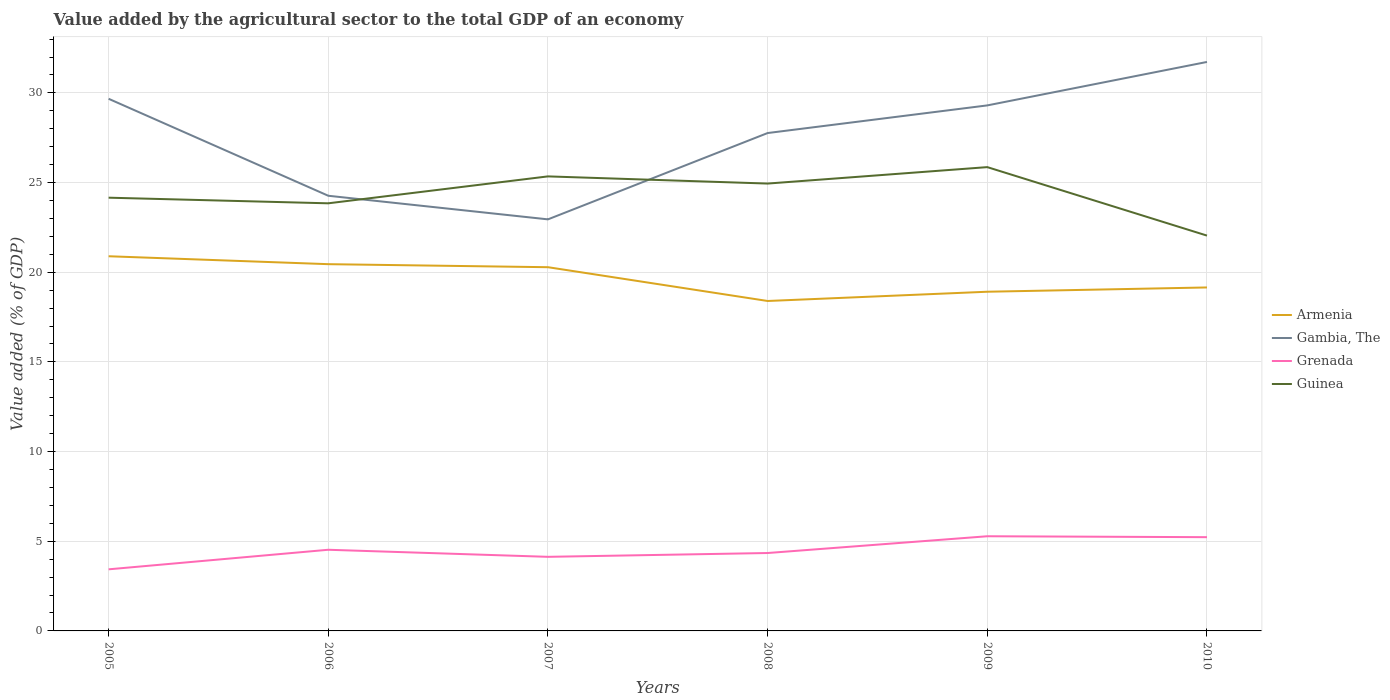How many different coloured lines are there?
Provide a short and direct response. 4. Is the number of lines equal to the number of legend labels?
Make the answer very short. Yes. Across all years, what is the maximum value added by the agricultural sector to the total GDP in Guinea?
Give a very brief answer. 22.04. In which year was the value added by the agricultural sector to the total GDP in Guinea maximum?
Provide a succinct answer. 2010. What is the total value added by the agricultural sector to the total GDP in Guinea in the graph?
Offer a terse response. 0.4. What is the difference between the highest and the second highest value added by the agricultural sector to the total GDP in Grenada?
Give a very brief answer. 1.84. Is the value added by the agricultural sector to the total GDP in Armenia strictly greater than the value added by the agricultural sector to the total GDP in Gambia, The over the years?
Make the answer very short. Yes. How many lines are there?
Provide a short and direct response. 4. Does the graph contain any zero values?
Provide a succinct answer. No. Does the graph contain grids?
Your answer should be compact. Yes. How are the legend labels stacked?
Give a very brief answer. Vertical. What is the title of the graph?
Your answer should be compact. Value added by the agricultural sector to the total GDP of an economy. What is the label or title of the X-axis?
Offer a terse response. Years. What is the label or title of the Y-axis?
Provide a succinct answer. Value added (% of GDP). What is the Value added (% of GDP) in Armenia in 2005?
Ensure brevity in your answer.  20.89. What is the Value added (% of GDP) of Gambia, The in 2005?
Make the answer very short. 29.67. What is the Value added (% of GDP) of Grenada in 2005?
Keep it short and to the point. 3.43. What is the Value added (% of GDP) of Guinea in 2005?
Your response must be concise. 24.16. What is the Value added (% of GDP) of Armenia in 2006?
Give a very brief answer. 20.45. What is the Value added (% of GDP) of Gambia, The in 2006?
Provide a succinct answer. 24.27. What is the Value added (% of GDP) of Grenada in 2006?
Provide a succinct answer. 4.53. What is the Value added (% of GDP) in Guinea in 2006?
Make the answer very short. 23.84. What is the Value added (% of GDP) in Armenia in 2007?
Ensure brevity in your answer.  20.28. What is the Value added (% of GDP) in Gambia, The in 2007?
Your answer should be compact. 22.95. What is the Value added (% of GDP) of Grenada in 2007?
Keep it short and to the point. 4.13. What is the Value added (% of GDP) in Guinea in 2007?
Your response must be concise. 25.35. What is the Value added (% of GDP) in Armenia in 2008?
Ensure brevity in your answer.  18.4. What is the Value added (% of GDP) of Gambia, The in 2008?
Keep it short and to the point. 27.76. What is the Value added (% of GDP) in Grenada in 2008?
Keep it short and to the point. 4.34. What is the Value added (% of GDP) of Guinea in 2008?
Your answer should be compact. 24.95. What is the Value added (% of GDP) in Armenia in 2009?
Provide a short and direct response. 18.91. What is the Value added (% of GDP) in Gambia, The in 2009?
Give a very brief answer. 29.3. What is the Value added (% of GDP) of Grenada in 2009?
Your answer should be compact. 5.28. What is the Value added (% of GDP) in Guinea in 2009?
Keep it short and to the point. 25.86. What is the Value added (% of GDP) of Armenia in 2010?
Offer a terse response. 19.15. What is the Value added (% of GDP) of Gambia, The in 2010?
Make the answer very short. 31.73. What is the Value added (% of GDP) in Grenada in 2010?
Your answer should be very brief. 5.23. What is the Value added (% of GDP) of Guinea in 2010?
Provide a succinct answer. 22.04. Across all years, what is the maximum Value added (% of GDP) of Armenia?
Your answer should be very brief. 20.89. Across all years, what is the maximum Value added (% of GDP) of Gambia, The?
Offer a terse response. 31.73. Across all years, what is the maximum Value added (% of GDP) of Grenada?
Offer a terse response. 5.28. Across all years, what is the maximum Value added (% of GDP) of Guinea?
Your answer should be very brief. 25.86. Across all years, what is the minimum Value added (% of GDP) in Armenia?
Offer a terse response. 18.4. Across all years, what is the minimum Value added (% of GDP) in Gambia, The?
Your response must be concise. 22.95. Across all years, what is the minimum Value added (% of GDP) in Grenada?
Keep it short and to the point. 3.43. Across all years, what is the minimum Value added (% of GDP) of Guinea?
Ensure brevity in your answer.  22.04. What is the total Value added (% of GDP) in Armenia in the graph?
Your response must be concise. 118.09. What is the total Value added (% of GDP) of Gambia, The in the graph?
Ensure brevity in your answer.  165.68. What is the total Value added (% of GDP) in Grenada in the graph?
Offer a terse response. 26.94. What is the total Value added (% of GDP) in Guinea in the graph?
Your answer should be compact. 146.2. What is the difference between the Value added (% of GDP) in Armenia in 2005 and that in 2006?
Your response must be concise. 0.44. What is the difference between the Value added (% of GDP) in Gambia, The in 2005 and that in 2006?
Provide a short and direct response. 5.41. What is the difference between the Value added (% of GDP) in Grenada in 2005 and that in 2006?
Your response must be concise. -1.09. What is the difference between the Value added (% of GDP) of Guinea in 2005 and that in 2006?
Provide a succinct answer. 0.31. What is the difference between the Value added (% of GDP) of Armenia in 2005 and that in 2007?
Ensure brevity in your answer.  0.61. What is the difference between the Value added (% of GDP) of Gambia, The in 2005 and that in 2007?
Your answer should be very brief. 6.72. What is the difference between the Value added (% of GDP) in Grenada in 2005 and that in 2007?
Ensure brevity in your answer.  -0.7. What is the difference between the Value added (% of GDP) in Guinea in 2005 and that in 2007?
Make the answer very short. -1.19. What is the difference between the Value added (% of GDP) of Armenia in 2005 and that in 2008?
Make the answer very short. 2.49. What is the difference between the Value added (% of GDP) of Gambia, The in 2005 and that in 2008?
Your response must be concise. 1.91. What is the difference between the Value added (% of GDP) in Grenada in 2005 and that in 2008?
Offer a very short reply. -0.91. What is the difference between the Value added (% of GDP) of Guinea in 2005 and that in 2008?
Offer a very short reply. -0.79. What is the difference between the Value added (% of GDP) of Armenia in 2005 and that in 2009?
Make the answer very short. 1.98. What is the difference between the Value added (% of GDP) of Gambia, The in 2005 and that in 2009?
Provide a succinct answer. 0.37. What is the difference between the Value added (% of GDP) of Grenada in 2005 and that in 2009?
Provide a succinct answer. -1.84. What is the difference between the Value added (% of GDP) of Guinea in 2005 and that in 2009?
Ensure brevity in your answer.  -1.7. What is the difference between the Value added (% of GDP) in Armenia in 2005 and that in 2010?
Your answer should be very brief. 1.74. What is the difference between the Value added (% of GDP) in Gambia, The in 2005 and that in 2010?
Your answer should be compact. -2.05. What is the difference between the Value added (% of GDP) in Grenada in 2005 and that in 2010?
Your response must be concise. -1.79. What is the difference between the Value added (% of GDP) of Guinea in 2005 and that in 2010?
Your answer should be compact. 2.11. What is the difference between the Value added (% of GDP) of Armenia in 2006 and that in 2007?
Your response must be concise. 0.17. What is the difference between the Value added (% of GDP) of Gambia, The in 2006 and that in 2007?
Offer a terse response. 1.32. What is the difference between the Value added (% of GDP) in Grenada in 2006 and that in 2007?
Offer a very short reply. 0.39. What is the difference between the Value added (% of GDP) in Guinea in 2006 and that in 2007?
Keep it short and to the point. -1.5. What is the difference between the Value added (% of GDP) of Armenia in 2006 and that in 2008?
Keep it short and to the point. 2.05. What is the difference between the Value added (% of GDP) of Gambia, The in 2006 and that in 2008?
Make the answer very short. -3.5. What is the difference between the Value added (% of GDP) in Grenada in 2006 and that in 2008?
Keep it short and to the point. 0.18. What is the difference between the Value added (% of GDP) of Guinea in 2006 and that in 2008?
Ensure brevity in your answer.  -1.1. What is the difference between the Value added (% of GDP) in Armenia in 2006 and that in 2009?
Your answer should be compact. 1.54. What is the difference between the Value added (% of GDP) in Gambia, The in 2006 and that in 2009?
Give a very brief answer. -5.04. What is the difference between the Value added (% of GDP) in Grenada in 2006 and that in 2009?
Offer a terse response. -0.75. What is the difference between the Value added (% of GDP) of Guinea in 2006 and that in 2009?
Offer a very short reply. -2.02. What is the difference between the Value added (% of GDP) of Armenia in 2006 and that in 2010?
Your answer should be compact. 1.3. What is the difference between the Value added (% of GDP) in Gambia, The in 2006 and that in 2010?
Offer a terse response. -7.46. What is the difference between the Value added (% of GDP) in Grenada in 2006 and that in 2010?
Provide a succinct answer. -0.7. What is the difference between the Value added (% of GDP) in Guinea in 2006 and that in 2010?
Your response must be concise. 1.8. What is the difference between the Value added (% of GDP) in Armenia in 2007 and that in 2008?
Your response must be concise. 1.88. What is the difference between the Value added (% of GDP) in Gambia, The in 2007 and that in 2008?
Offer a terse response. -4.81. What is the difference between the Value added (% of GDP) in Grenada in 2007 and that in 2008?
Provide a short and direct response. -0.21. What is the difference between the Value added (% of GDP) of Guinea in 2007 and that in 2008?
Offer a very short reply. 0.4. What is the difference between the Value added (% of GDP) in Armenia in 2007 and that in 2009?
Give a very brief answer. 1.37. What is the difference between the Value added (% of GDP) of Gambia, The in 2007 and that in 2009?
Your answer should be compact. -6.35. What is the difference between the Value added (% of GDP) in Grenada in 2007 and that in 2009?
Ensure brevity in your answer.  -1.15. What is the difference between the Value added (% of GDP) of Guinea in 2007 and that in 2009?
Your response must be concise. -0.52. What is the difference between the Value added (% of GDP) in Armenia in 2007 and that in 2010?
Provide a short and direct response. 1.13. What is the difference between the Value added (% of GDP) of Gambia, The in 2007 and that in 2010?
Give a very brief answer. -8.78. What is the difference between the Value added (% of GDP) in Grenada in 2007 and that in 2010?
Offer a very short reply. -1.1. What is the difference between the Value added (% of GDP) of Guinea in 2007 and that in 2010?
Provide a short and direct response. 3.3. What is the difference between the Value added (% of GDP) of Armenia in 2008 and that in 2009?
Provide a short and direct response. -0.52. What is the difference between the Value added (% of GDP) in Gambia, The in 2008 and that in 2009?
Make the answer very short. -1.54. What is the difference between the Value added (% of GDP) in Grenada in 2008 and that in 2009?
Keep it short and to the point. -0.94. What is the difference between the Value added (% of GDP) in Guinea in 2008 and that in 2009?
Offer a terse response. -0.92. What is the difference between the Value added (% of GDP) of Armenia in 2008 and that in 2010?
Offer a terse response. -0.75. What is the difference between the Value added (% of GDP) of Gambia, The in 2008 and that in 2010?
Make the answer very short. -3.96. What is the difference between the Value added (% of GDP) of Grenada in 2008 and that in 2010?
Your answer should be compact. -0.88. What is the difference between the Value added (% of GDP) in Guinea in 2008 and that in 2010?
Provide a short and direct response. 2.9. What is the difference between the Value added (% of GDP) of Armenia in 2009 and that in 2010?
Offer a very short reply. -0.24. What is the difference between the Value added (% of GDP) of Gambia, The in 2009 and that in 2010?
Your response must be concise. -2.42. What is the difference between the Value added (% of GDP) of Grenada in 2009 and that in 2010?
Your response must be concise. 0.05. What is the difference between the Value added (% of GDP) in Guinea in 2009 and that in 2010?
Offer a very short reply. 3.82. What is the difference between the Value added (% of GDP) in Armenia in 2005 and the Value added (% of GDP) in Gambia, The in 2006?
Offer a very short reply. -3.37. What is the difference between the Value added (% of GDP) of Armenia in 2005 and the Value added (% of GDP) of Grenada in 2006?
Provide a succinct answer. 16.37. What is the difference between the Value added (% of GDP) of Armenia in 2005 and the Value added (% of GDP) of Guinea in 2006?
Provide a succinct answer. -2.95. What is the difference between the Value added (% of GDP) of Gambia, The in 2005 and the Value added (% of GDP) of Grenada in 2006?
Offer a very short reply. 25.15. What is the difference between the Value added (% of GDP) of Gambia, The in 2005 and the Value added (% of GDP) of Guinea in 2006?
Make the answer very short. 5.83. What is the difference between the Value added (% of GDP) in Grenada in 2005 and the Value added (% of GDP) in Guinea in 2006?
Provide a succinct answer. -20.41. What is the difference between the Value added (% of GDP) of Armenia in 2005 and the Value added (% of GDP) of Gambia, The in 2007?
Give a very brief answer. -2.06. What is the difference between the Value added (% of GDP) of Armenia in 2005 and the Value added (% of GDP) of Grenada in 2007?
Make the answer very short. 16.76. What is the difference between the Value added (% of GDP) in Armenia in 2005 and the Value added (% of GDP) in Guinea in 2007?
Your response must be concise. -4.45. What is the difference between the Value added (% of GDP) in Gambia, The in 2005 and the Value added (% of GDP) in Grenada in 2007?
Keep it short and to the point. 25.54. What is the difference between the Value added (% of GDP) of Gambia, The in 2005 and the Value added (% of GDP) of Guinea in 2007?
Your answer should be very brief. 4.33. What is the difference between the Value added (% of GDP) of Grenada in 2005 and the Value added (% of GDP) of Guinea in 2007?
Your answer should be very brief. -21.91. What is the difference between the Value added (% of GDP) in Armenia in 2005 and the Value added (% of GDP) in Gambia, The in 2008?
Your response must be concise. -6.87. What is the difference between the Value added (% of GDP) in Armenia in 2005 and the Value added (% of GDP) in Grenada in 2008?
Your response must be concise. 16.55. What is the difference between the Value added (% of GDP) of Armenia in 2005 and the Value added (% of GDP) of Guinea in 2008?
Offer a very short reply. -4.05. What is the difference between the Value added (% of GDP) of Gambia, The in 2005 and the Value added (% of GDP) of Grenada in 2008?
Offer a very short reply. 25.33. What is the difference between the Value added (% of GDP) in Gambia, The in 2005 and the Value added (% of GDP) in Guinea in 2008?
Provide a succinct answer. 4.73. What is the difference between the Value added (% of GDP) of Grenada in 2005 and the Value added (% of GDP) of Guinea in 2008?
Your answer should be compact. -21.51. What is the difference between the Value added (% of GDP) in Armenia in 2005 and the Value added (% of GDP) in Gambia, The in 2009?
Give a very brief answer. -8.41. What is the difference between the Value added (% of GDP) of Armenia in 2005 and the Value added (% of GDP) of Grenada in 2009?
Make the answer very short. 15.61. What is the difference between the Value added (% of GDP) of Armenia in 2005 and the Value added (% of GDP) of Guinea in 2009?
Provide a succinct answer. -4.97. What is the difference between the Value added (% of GDP) of Gambia, The in 2005 and the Value added (% of GDP) of Grenada in 2009?
Your answer should be very brief. 24.39. What is the difference between the Value added (% of GDP) of Gambia, The in 2005 and the Value added (% of GDP) of Guinea in 2009?
Give a very brief answer. 3.81. What is the difference between the Value added (% of GDP) of Grenada in 2005 and the Value added (% of GDP) of Guinea in 2009?
Ensure brevity in your answer.  -22.43. What is the difference between the Value added (% of GDP) in Armenia in 2005 and the Value added (% of GDP) in Gambia, The in 2010?
Your answer should be very brief. -10.84. What is the difference between the Value added (% of GDP) in Armenia in 2005 and the Value added (% of GDP) in Grenada in 2010?
Offer a terse response. 15.66. What is the difference between the Value added (% of GDP) in Armenia in 2005 and the Value added (% of GDP) in Guinea in 2010?
Offer a terse response. -1.15. What is the difference between the Value added (% of GDP) in Gambia, The in 2005 and the Value added (% of GDP) in Grenada in 2010?
Your response must be concise. 24.45. What is the difference between the Value added (% of GDP) in Gambia, The in 2005 and the Value added (% of GDP) in Guinea in 2010?
Your response must be concise. 7.63. What is the difference between the Value added (% of GDP) of Grenada in 2005 and the Value added (% of GDP) of Guinea in 2010?
Ensure brevity in your answer.  -18.61. What is the difference between the Value added (% of GDP) of Armenia in 2006 and the Value added (% of GDP) of Gambia, The in 2007?
Provide a succinct answer. -2.5. What is the difference between the Value added (% of GDP) in Armenia in 2006 and the Value added (% of GDP) in Grenada in 2007?
Provide a succinct answer. 16.32. What is the difference between the Value added (% of GDP) of Armenia in 2006 and the Value added (% of GDP) of Guinea in 2007?
Keep it short and to the point. -4.89. What is the difference between the Value added (% of GDP) of Gambia, The in 2006 and the Value added (% of GDP) of Grenada in 2007?
Your answer should be very brief. 20.13. What is the difference between the Value added (% of GDP) of Gambia, The in 2006 and the Value added (% of GDP) of Guinea in 2007?
Keep it short and to the point. -1.08. What is the difference between the Value added (% of GDP) in Grenada in 2006 and the Value added (% of GDP) in Guinea in 2007?
Provide a short and direct response. -20.82. What is the difference between the Value added (% of GDP) of Armenia in 2006 and the Value added (% of GDP) of Gambia, The in 2008?
Keep it short and to the point. -7.31. What is the difference between the Value added (% of GDP) of Armenia in 2006 and the Value added (% of GDP) of Grenada in 2008?
Ensure brevity in your answer.  16.11. What is the difference between the Value added (% of GDP) of Armenia in 2006 and the Value added (% of GDP) of Guinea in 2008?
Your response must be concise. -4.49. What is the difference between the Value added (% of GDP) in Gambia, The in 2006 and the Value added (% of GDP) in Grenada in 2008?
Provide a short and direct response. 19.92. What is the difference between the Value added (% of GDP) of Gambia, The in 2006 and the Value added (% of GDP) of Guinea in 2008?
Your answer should be compact. -0.68. What is the difference between the Value added (% of GDP) in Grenada in 2006 and the Value added (% of GDP) in Guinea in 2008?
Your answer should be compact. -20.42. What is the difference between the Value added (% of GDP) in Armenia in 2006 and the Value added (% of GDP) in Gambia, The in 2009?
Make the answer very short. -8.85. What is the difference between the Value added (% of GDP) in Armenia in 2006 and the Value added (% of GDP) in Grenada in 2009?
Offer a very short reply. 15.17. What is the difference between the Value added (% of GDP) of Armenia in 2006 and the Value added (% of GDP) of Guinea in 2009?
Your answer should be compact. -5.41. What is the difference between the Value added (% of GDP) of Gambia, The in 2006 and the Value added (% of GDP) of Grenada in 2009?
Offer a very short reply. 18.99. What is the difference between the Value added (% of GDP) of Gambia, The in 2006 and the Value added (% of GDP) of Guinea in 2009?
Ensure brevity in your answer.  -1.6. What is the difference between the Value added (% of GDP) in Grenada in 2006 and the Value added (% of GDP) in Guinea in 2009?
Your answer should be compact. -21.34. What is the difference between the Value added (% of GDP) of Armenia in 2006 and the Value added (% of GDP) of Gambia, The in 2010?
Make the answer very short. -11.28. What is the difference between the Value added (% of GDP) in Armenia in 2006 and the Value added (% of GDP) in Grenada in 2010?
Offer a terse response. 15.22. What is the difference between the Value added (% of GDP) of Armenia in 2006 and the Value added (% of GDP) of Guinea in 2010?
Your response must be concise. -1.59. What is the difference between the Value added (% of GDP) of Gambia, The in 2006 and the Value added (% of GDP) of Grenada in 2010?
Your answer should be very brief. 19.04. What is the difference between the Value added (% of GDP) in Gambia, The in 2006 and the Value added (% of GDP) in Guinea in 2010?
Your answer should be compact. 2.22. What is the difference between the Value added (% of GDP) in Grenada in 2006 and the Value added (% of GDP) in Guinea in 2010?
Make the answer very short. -17.52. What is the difference between the Value added (% of GDP) in Armenia in 2007 and the Value added (% of GDP) in Gambia, The in 2008?
Your answer should be compact. -7.48. What is the difference between the Value added (% of GDP) of Armenia in 2007 and the Value added (% of GDP) of Grenada in 2008?
Your answer should be compact. 15.94. What is the difference between the Value added (% of GDP) in Armenia in 2007 and the Value added (% of GDP) in Guinea in 2008?
Ensure brevity in your answer.  -4.66. What is the difference between the Value added (% of GDP) in Gambia, The in 2007 and the Value added (% of GDP) in Grenada in 2008?
Give a very brief answer. 18.61. What is the difference between the Value added (% of GDP) of Gambia, The in 2007 and the Value added (% of GDP) of Guinea in 2008?
Offer a terse response. -2. What is the difference between the Value added (% of GDP) in Grenada in 2007 and the Value added (% of GDP) in Guinea in 2008?
Keep it short and to the point. -20.81. What is the difference between the Value added (% of GDP) of Armenia in 2007 and the Value added (% of GDP) of Gambia, The in 2009?
Your response must be concise. -9.02. What is the difference between the Value added (% of GDP) in Armenia in 2007 and the Value added (% of GDP) in Grenada in 2009?
Offer a terse response. 15. What is the difference between the Value added (% of GDP) in Armenia in 2007 and the Value added (% of GDP) in Guinea in 2009?
Keep it short and to the point. -5.58. What is the difference between the Value added (% of GDP) of Gambia, The in 2007 and the Value added (% of GDP) of Grenada in 2009?
Ensure brevity in your answer.  17.67. What is the difference between the Value added (% of GDP) of Gambia, The in 2007 and the Value added (% of GDP) of Guinea in 2009?
Keep it short and to the point. -2.91. What is the difference between the Value added (% of GDP) of Grenada in 2007 and the Value added (% of GDP) of Guinea in 2009?
Your answer should be compact. -21.73. What is the difference between the Value added (% of GDP) in Armenia in 2007 and the Value added (% of GDP) in Gambia, The in 2010?
Give a very brief answer. -11.45. What is the difference between the Value added (% of GDP) in Armenia in 2007 and the Value added (% of GDP) in Grenada in 2010?
Offer a very short reply. 15.05. What is the difference between the Value added (% of GDP) of Armenia in 2007 and the Value added (% of GDP) of Guinea in 2010?
Keep it short and to the point. -1.76. What is the difference between the Value added (% of GDP) in Gambia, The in 2007 and the Value added (% of GDP) in Grenada in 2010?
Your response must be concise. 17.72. What is the difference between the Value added (% of GDP) in Gambia, The in 2007 and the Value added (% of GDP) in Guinea in 2010?
Ensure brevity in your answer.  0.91. What is the difference between the Value added (% of GDP) in Grenada in 2007 and the Value added (% of GDP) in Guinea in 2010?
Your answer should be compact. -17.91. What is the difference between the Value added (% of GDP) in Armenia in 2008 and the Value added (% of GDP) in Gambia, The in 2009?
Ensure brevity in your answer.  -10.91. What is the difference between the Value added (% of GDP) in Armenia in 2008 and the Value added (% of GDP) in Grenada in 2009?
Your answer should be very brief. 13.12. What is the difference between the Value added (% of GDP) of Armenia in 2008 and the Value added (% of GDP) of Guinea in 2009?
Provide a short and direct response. -7.46. What is the difference between the Value added (% of GDP) in Gambia, The in 2008 and the Value added (% of GDP) in Grenada in 2009?
Keep it short and to the point. 22.48. What is the difference between the Value added (% of GDP) of Gambia, The in 2008 and the Value added (% of GDP) of Guinea in 2009?
Provide a succinct answer. 1.9. What is the difference between the Value added (% of GDP) of Grenada in 2008 and the Value added (% of GDP) of Guinea in 2009?
Provide a succinct answer. -21.52. What is the difference between the Value added (% of GDP) of Armenia in 2008 and the Value added (% of GDP) of Gambia, The in 2010?
Keep it short and to the point. -13.33. What is the difference between the Value added (% of GDP) in Armenia in 2008 and the Value added (% of GDP) in Grenada in 2010?
Offer a very short reply. 13.17. What is the difference between the Value added (% of GDP) of Armenia in 2008 and the Value added (% of GDP) of Guinea in 2010?
Your answer should be compact. -3.65. What is the difference between the Value added (% of GDP) in Gambia, The in 2008 and the Value added (% of GDP) in Grenada in 2010?
Provide a succinct answer. 22.54. What is the difference between the Value added (% of GDP) of Gambia, The in 2008 and the Value added (% of GDP) of Guinea in 2010?
Offer a terse response. 5.72. What is the difference between the Value added (% of GDP) in Grenada in 2008 and the Value added (% of GDP) in Guinea in 2010?
Offer a terse response. -17.7. What is the difference between the Value added (% of GDP) of Armenia in 2009 and the Value added (% of GDP) of Gambia, The in 2010?
Offer a very short reply. -12.81. What is the difference between the Value added (% of GDP) of Armenia in 2009 and the Value added (% of GDP) of Grenada in 2010?
Your answer should be very brief. 13.69. What is the difference between the Value added (% of GDP) of Armenia in 2009 and the Value added (% of GDP) of Guinea in 2010?
Your answer should be compact. -3.13. What is the difference between the Value added (% of GDP) in Gambia, The in 2009 and the Value added (% of GDP) in Grenada in 2010?
Keep it short and to the point. 24.08. What is the difference between the Value added (% of GDP) of Gambia, The in 2009 and the Value added (% of GDP) of Guinea in 2010?
Provide a succinct answer. 7.26. What is the difference between the Value added (% of GDP) in Grenada in 2009 and the Value added (% of GDP) in Guinea in 2010?
Ensure brevity in your answer.  -16.77. What is the average Value added (% of GDP) of Armenia per year?
Provide a succinct answer. 19.68. What is the average Value added (% of GDP) of Gambia, The per year?
Ensure brevity in your answer.  27.61. What is the average Value added (% of GDP) in Grenada per year?
Give a very brief answer. 4.49. What is the average Value added (% of GDP) in Guinea per year?
Your answer should be compact. 24.37. In the year 2005, what is the difference between the Value added (% of GDP) of Armenia and Value added (% of GDP) of Gambia, The?
Your answer should be compact. -8.78. In the year 2005, what is the difference between the Value added (% of GDP) in Armenia and Value added (% of GDP) in Grenada?
Your response must be concise. 17.46. In the year 2005, what is the difference between the Value added (% of GDP) of Armenia and Value added (% of GDP) of Guinea?
Your answer should be compact. -3.27. In the year 2005, what is the difference between the Value added (% of GDP) of Gambia, The and Value added (% of GDP) of Grenada?
Your response must be concise. 26.24. In the year 2005, what is the difference between the Value added (% of GDP) of Gambia, The and Value added (% of GDP) of Guinea?
Give a very brief answer. 5.51. In the year 2005, what is the difference between the Value added (% of GDP) of Grenada and Value added (% of GDP) of Guinea?
Your answer should be very brief. -20.72. In the year 2006, what is the difference between the Value added (% of GDP) in Armenia and Value added (% of GDP) in Gambia, The?
Your response must be concise. -3.81. In the year 2006, what is the difference between the Value added (% of GDP) of Armenia and Value added (% of GDP) of Grenada?
Ensure brevity in your answer.  15.93. In the year 2006, what is the difference between the Value added (% of GDP) of Armenia and Value added (% of GDP) of Guinea?
Ensure brevity in your answer.  -3.39. In the year 2006, what is the difference between the Value added (% of GDP) of Gambia, The and Value added (% of GDP) of Grenada?
Ensure brevity in your answer.  19.74. In the year 2006, what is the difference between the Value added (% of GDP) of Gambia, The and Value added (% of GDP) of Guinea?
Make the answer very short. 0.42. In the year 2006, what is the difference between the Value added (% of GDP) in Grenada and Value added (% of GDP) in Guinea?
Provide a succinct answer. -19.32. In the year 2007, what is the difference between the Value added (% of GDP) in Armenia and Value added (% of GDP) in Gambia, The?
Offer a terse response. -2.67. In the year 2007, what is the difference between the Value added (% of GDP) in Armenia and Value added (% of GDP) in Grenada?
Your answer should be very brief. 16.15. In the year 2007, what is the difference between the Value added (% of GDP) of Armenia and Value added (% of GDP) of Guinea?
Keep it short and to the point. -5.06. In the year 2007, what is the difference between the Value added (% of GDP) of Gambia, The and Value added (% of GDP) of Grenada?
Offer a very short reply. 18.82. In the year 2007, what is the difference between the Value added (% of GDP) in Gambia, The and Value added (% of GDP) in Guinea?
Ensure brevity in your answer.  -2.4. In the year 2007, what is the difference between the Value added (% of GDP) in Grenada and Value added (% of GDP) in Guinea?
Provide a short and direct response. -21.21. In the year 2008, what is the difference between the Value added (% of GDP) of Armenia and Value added (% of GDP) of Gambia, The?
Your answer should be very brief. -9.37. In the year 2008, what is the difference between the Value added (% of GDP) in Armenia and Value added (% of GDP) in Grenada?
Offer a very short reply. 14.05. In the year 2008, what is the difference between the Value added (% of GDP) in Armenia and Value added (% of GDP) in Guinea?
Your response must be concise. -6.55. In the year 2008, what is the difference between the Value added (% of GDP) in Gambia, The and Value added (% of GDP) in Grenada?
Give a very brief answer. 23.42. In the year 2008, what is the difference between the Value added (% of GDP) of Gambia, The and Value added (% of GDP) of Guinea?
Offer a terse response. 2.82. In the year 2008, what is the difference between the Value added (% of GDP) in Grenada and Value added (% of GDP) in Guinea?
Your answer should be very brief. -20.6. In the year 2009, what is the difference between the Value added (% of GDP) of Armenia and Value added (% of GDP) of Gambia, The?
Provide a succinct answer. -10.39. In the year 2009, what is the difference between the Value added (% of GDP) in Armenia and Value added (% of GDP) in Grenada?
Your response must be concise. 13.63. In the year 2009, what is the difference between the Value added (% of GDP) in Armenia and Value added (% of GDP) in Guinea?
Your response must be concise. -6.95. In the year 2009, what is the difference between the Value added (% of GDP) in Gambia, The and Value added (% of GDP) in Grenada?
Your answer should be very brief. 24.03. In the year 2009, what is the difference between the Value added (% of GDP) of Gambia, The and Value added (% of GDP) of Guinea?
Your answer should be compact. 3.44. In the year 2009, what is the difference between the Value added (% of GDP) in Grenada and Value added (% of GDP) in Guinea?
Provide a short and direct response. -20.58. In the year 2010, what is the difference between the Value added (% of GDP) in Armenia and Value added (% of GDP) in Gambia, The?
Give a very brief answer. -12.57. In the year 2010, what is the difference between the Value added (% of GDP) in Armenia and Value added (% of GDP) in Grenada?
Your answer should be compact. 13.93. In the year 2010, what is the difference between the Value added (% of GDP) in Armenia and Value added (% of GDP) in Guinea?
Offer a terse response. -2.89. In the year 2010, what is the difference between the Value added (% of GDP) in Gambia, The and Value added (% of GDP) in Grenada?
Keep it short and to the point. 26.5. In the year 2010, what is the difference between the Value added (% of GDP) in Gambia, The and Value added (% of GDP) in Guinea?
Provide a short and direct response. 9.68. In the year 2010, what is the difference between the Value added (% of GDP) in Grenada and Value added (% of GDP) in Guinea?
Provide a short and direct response. -16.82. What is the ratio of the Value added (% of GDP) in Armenia in 2005 to that in 2006?
Make the answer very short. 1.02. What is the ratio of the Value added (% of GDP) in Gambia, The in 2005 to that in 2006?
Your response must be concise. 1.22. What is the ratio of the Value added (% of GDP) of Grenada in 2005 to that in 2006?
Provide a succinct answer. 0.76. What is the ratio of the Value added (% of GDP) in Guinea in 2005 to that in 2006?
Keep it short and to the point. 1.01. What is the ratio of the Value added (% of GDP) in Armenia in 2005 to that in 2007?
Keep it short and to the point. 1.03. What is the ratio of the Value added (% of GDP) in Gambia, The in 2005 to that in 2007?
Your answer should be very brief. 1.29. What is the ratio of the Value added (% of GDP) in Grenada in 2005 to that in 2007?
Your answer should be very brief. 0.83. What is the ratio of the Value added (% of GDP) of Guinea in 2005 to that in 2007?
Ensure brevity in your answer.  0.95. What is the ratio of the Value added (% of GDP) in Armenia in 2005 to that in 2008?
Offer a very short reply. 1.14. What is the ratio of the Value added (% of GDP) of Gambia, The in 2005 to that in 2008?
Ensure brevity in your answer.  1.07. What is the ratio of the Value added (% of GDP) of Grenada in 2005 to that in 2008?
Offer a very short reply. 0.79. What is the ratio of the Value added (% of GDP) in Guinea in 2005 to that in 2008?
Offer a terse response. 0.97. What is the ratio of the Value added (% of GDP) of Armenia in 2005 to that in 2009?
Offer a very short reply. 1.1. What is the ratio of the Value added (% of GDP) of Gambia, The in 2005 to that in 2009?
Provide a short and direct response. 1.01. What is the ratio of the Value added (% of GDP) in Grenada in 2005 to that in 2009?
Offer a very short reply. 0.65. What is the ratio of the Value added (% of GDP) in Guinea in 2005 to that in 2009?
Ensure brevity in your answer.  0.93. What is the ratio of the Value added (% of GDP) of Armenia in 2005 to that in 2010?
Keep it short and to the point. 1.09. What is the ratio of the Value added (% of GDP) in Gambia, The in 2005 to that in 2010?
Make the answer very short. 0.94. What is the ratio of the Value added (% of GDP) in Grenada in 2005 to that in 2010?
Provide a succinct answer. 0.66. What is the ratio of the Value added (% of GDP) of Guinea in 2005 to that in 2010?
Offer a very short reply. 1.1. What is the ratio of the Value added (% of GDP) in Armenia in 2006 to that in 2007?
Your answer should be compact. 1.01. What is the ratio of the Value added (% of GDP) in Gambia, The in 2006 to that in 2007?
Give a very brief answer. 1.06. What is the ratio of the Value added (% of GDP) in Grenada in 2006 to that in 2007?
Offer a terse response. 1.1. What is the ratio of the Value added (% of GDP) of Guinea in 2006 to that in 2007?
Your response must be concise. 0.94. What is the ratio of the Value added (% of GDP) in Armenia in 2006 to that in 2008?
Your answer should be very brief. 1.11. What is the ratio of the Value added (% of GDP) of Gambia, The in 2006 to that in 2008?
Provide a succinct answer. 0.87. What is the ratio of the Value added (% of GDP) in Grenada in 2006 to that in 2008?
Make the answer very short. 1.04. What is the ratio of the Value added (% of GDP) of Guinea in 2006 to that in 2008?
Your answer should be very brief. 0.96. What is the ratio of the Value added (% of GDP) in Armenia in 2006 to that in 2009?
Offer a very short reply. 1.08. What is the ratio of the Value added (% of GDP) of Gambia, The in 2006 to that in 2009?
Offer a very short reply. 0.83. What is the ratio of the Value added (% of GDP) in Grenada in 2006 to that in 2009?
Give a very brief answer. 0.86. What is the ratio of the Value added (% of GDP) of Guinea in 2006 to that in 2009?
Offer a very short reply. 0.92. What is the ratio of the Value added (% of GDP) of Armenia in 2006 to that in 2010?
Ensure brevity in your answer.  1.07. What is the ratio of the Value added (% of GDP) of Gambia, The in 2006 to that in 2010?
Make the answer very short. 0.76. What is the ratio of the Value added (% of GDP) in Grenada in 2006 to that in 2010?
Make the answer very short. 0.87. What is the ratio of the Value added (% of GDP) of Guinea in 2006 to that in 2010?
Ensure brevity in your answer.  1.08. What is the ratio of the Value added (% of GDP) of Armenia in 2007 to that in 2008?
Provide a short and direct response. 1.1. What is the ratio of the Value added (% of GDP) of Gambia, The in 2007 to that in 2008?
Offer a very short reply. 0.83. What is the ratio of the Value added (% of GDP) of Grenada in 2007 to that in 2008?
Your answer should be compact. 0.95. What is the ratio of the Value added (% of GDP) of Guinea in 2007 to that in 2008?
Offer a terse response. 1.02. What is the ratio of the Value added (% of GDP) in Armenia in 2007 to that in 2009?
Give a very brief answer. 1.07. What is the ratio of the Value added (% of GDP) in Gambia, The in 2007 to that in 2009?
Provide a short and direct response. 0.78. What is the ratio of the Value added (% of GDP) in Grenada in 2007 to that in 2009?
Provide a short and direct response. 0.78. What is the ratio of the Value added (% of GDP) of Guinea in 2007 to that in 2009?
Your answer should be very brief. 0.98. What is the ratio of the Value added (% of GDP) in Armenia in 2007 to that in 2010?
Keep it short and to the point. 1.06. What is the ratio of the Value added (% of GDP) in Gambia, The in 2007 to that in 2010?
Ensure brevity in your answer.  0.72. What is the ratio of the Value added (% of GDP) of Grenada in 2007 to that in 2010?
Give a very brief answer. 0.79. What is the ratio of the Value added (% of GDP) of Guinea in 2007 to that in 2010?
Your response must be concise. 1.15. What is the ratio of the Value added (% of GDP) of Armenia in 2008 to that in 2009?
Your answer should be compact. 0.97. What is the ratio of the Value added (% of GDP) of Grenada in 2008 to that in 2009?
Provide a succinct answer. 0.82. What is the ratio of the Value added (% of GDP) of Guinea in 2008 to that in 2009?
Your response must be concise. 0.96. What is the ratio of the Value added (% of GDP) of Armenia in 2008 to that in 2010?
Ensure brevity in your answer.  0.96. What is the ratio of the Value added (% of GDP) of Gambia, The in 2008 to that in 2010?
Ensure brevity in your answer.  0.88. What is the ratio of the Value added (% of GDP) of Grenada in 2008 to that in 2010?
Offer a very short reply. 0.83. What is the ratio of the Value added (% of GDP) of Guinea in 2008 to that in 2010?
Provide a short and direct response. 1.13. What is the ratio of the Value added (% of GDP) of Armenia in 2009 to that in 2010?
Provide a succinct answer. 0.99. What is the ratio of the Value added (% of GDP) in Gambia, The in 2009 to that in 2010?
Make the answer very short. 0.92. What is the ratio of the Value added (% of GDP) of Grenada in 2009 to that in 2010?
Offer a very short reply. 1.01. What is the ratio of the Value added (% of GDP) of Guinea in 2009 to that in 2010?
Keep it short and to the point. 1.17. What is the difference between the highest and the second highest Value added (% of GDP) in Armenia?
Offer a very short reply. 0.44. What is the difference between the highest and the second highest Value added (% of GDP) in Gambia, The?
Your response must be concise. 2.05. What is the difference between the highest and the second highest Value added (% of GDP) of Grenada?
Give a very brief answer. 0.05. What is the difference between the highest and the second highest Value added (% of GDP) in Guinea?
Provide a short and direct response. 0.52. What is the difference between the highest and the lowest Value added (% of GDP) of Armenia?
Your response must be concise. 2.49. What is the difference between the highest and the lowest Value added (% of GDP) of Gambia, The?
Your answer should be compact. 8.78. What is the difference between the highest and the lowest Value added (% of GDP) of Grenada?
Make the answer very short. 1.84. What is the difference between the highest and the lowest Value added (% of GDP) in Guinea?
Make the answer very short. 3.82. 